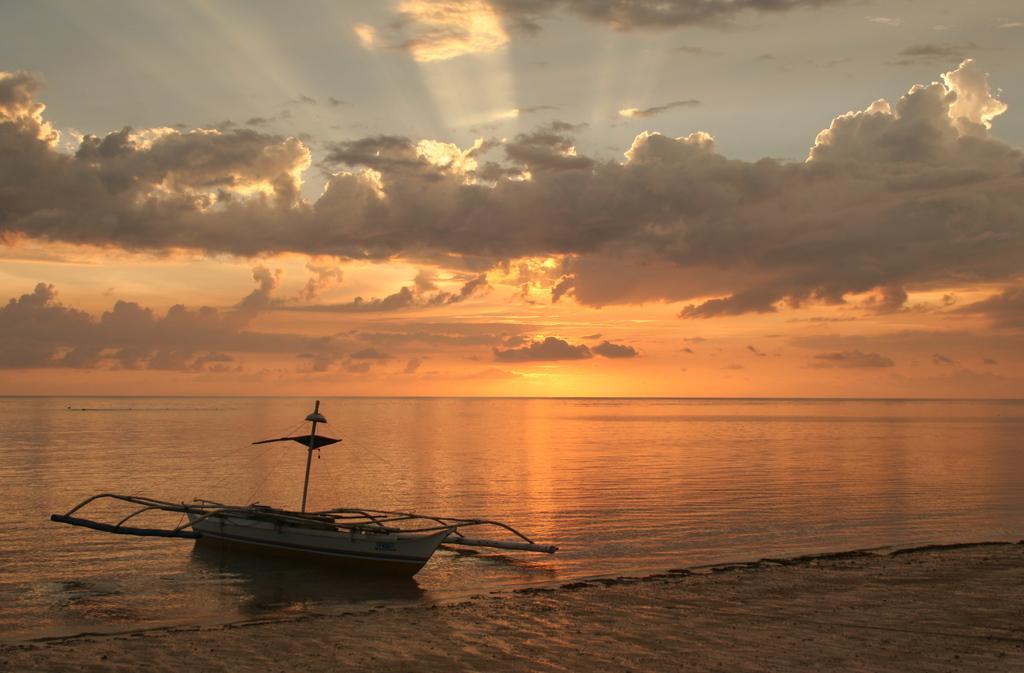Please provide a concise description of this image. This is an outside view and it is a beach. On the left side there is a boat on the water. At the top of the image, I can see the sky and clouds. 